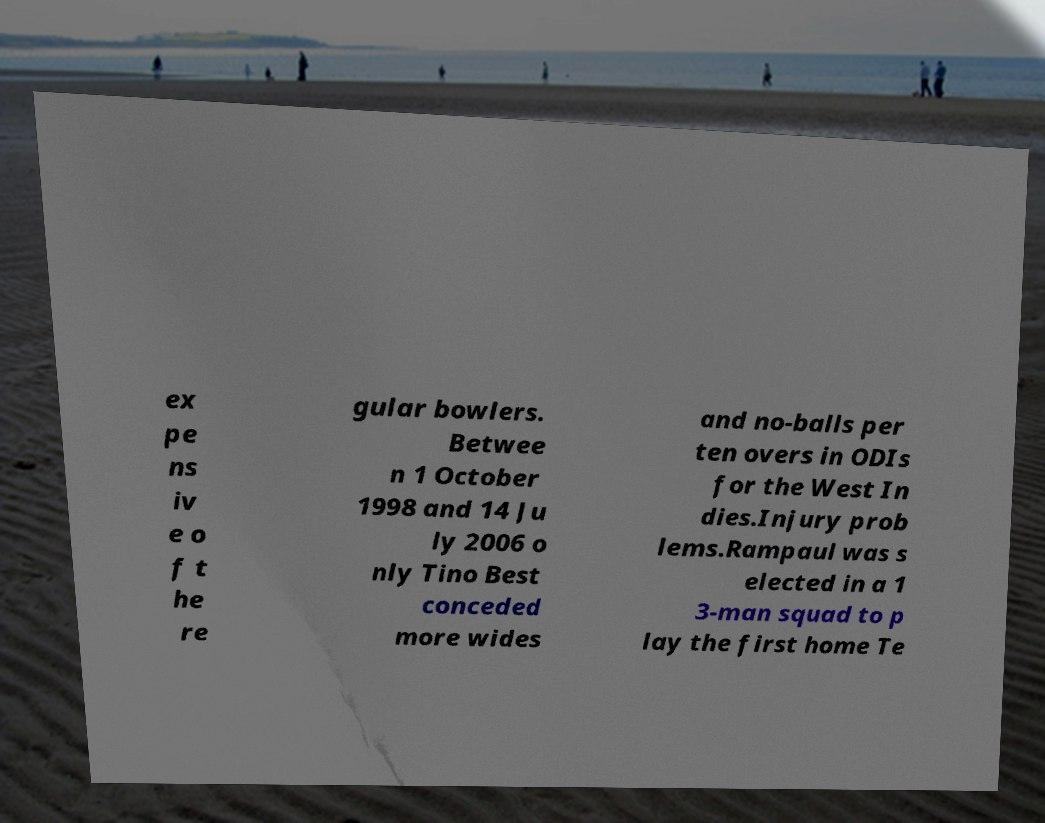Can you accurately transcribe the text from the provided image for me? ex pe ns iv e o f t he re gular bowlers. Betwee n 1 October 1998 and 14 Ju ly 2006 o nly Tino Best conceded more wides and no-balls per ten overs in ODIs for the West In dies.Injury prob lems.Rampaul was s elected in a 1 3-man squad to p lay the first home Te 